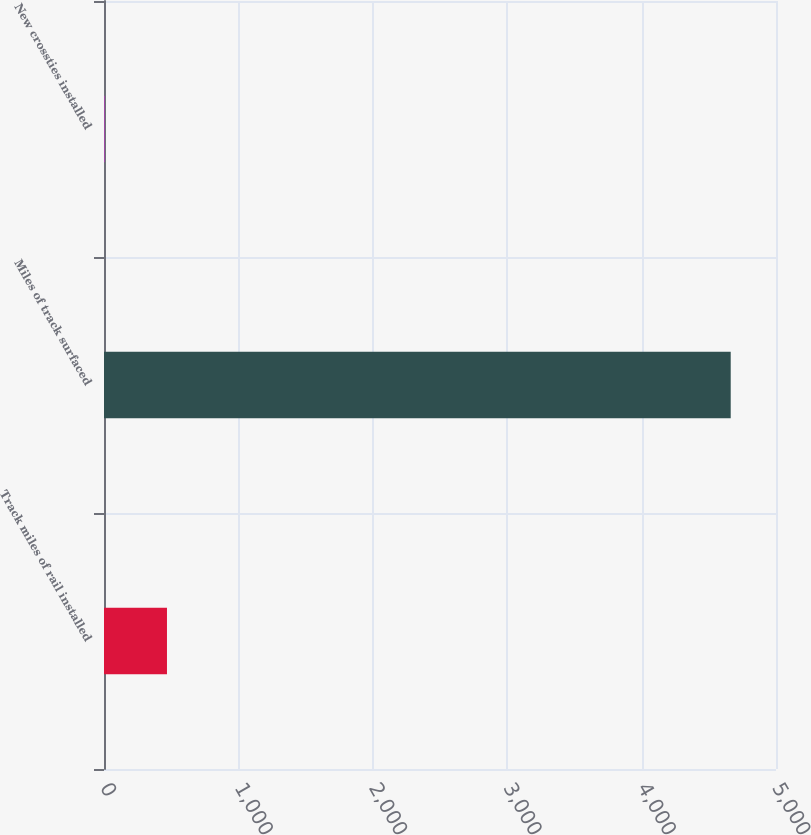Convert chart. <chart><loc_0><loc_0><loc_500><loc_500><bar_chart><fcel>Track miles of rail installed<fcel>Miles of track surfaced<fcel>New crossties installed<nl><fcel>468.55<fcel>4663<fcel>2.5<nl></chart> 